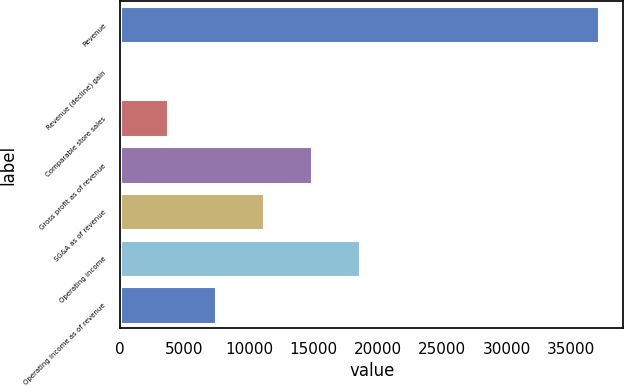Convert chart. <chart><loc_0><loc_0><loc_500><loc_500><bar_chart><fcel>Revenue<fcel>Revenue (decline) gain<fcel>Comparable store sales<fcel>Gross profit as of revenue<fcel>SG&A as of revenue<fcel>Operating income<fcel>Operating income as of revenue<nl><fcel>37186<fcel>0.3<fcel>3718.87<fcel>14874.6<fcel>11156<fcel>18593.2<fcel>7437.44<nl></chart> 